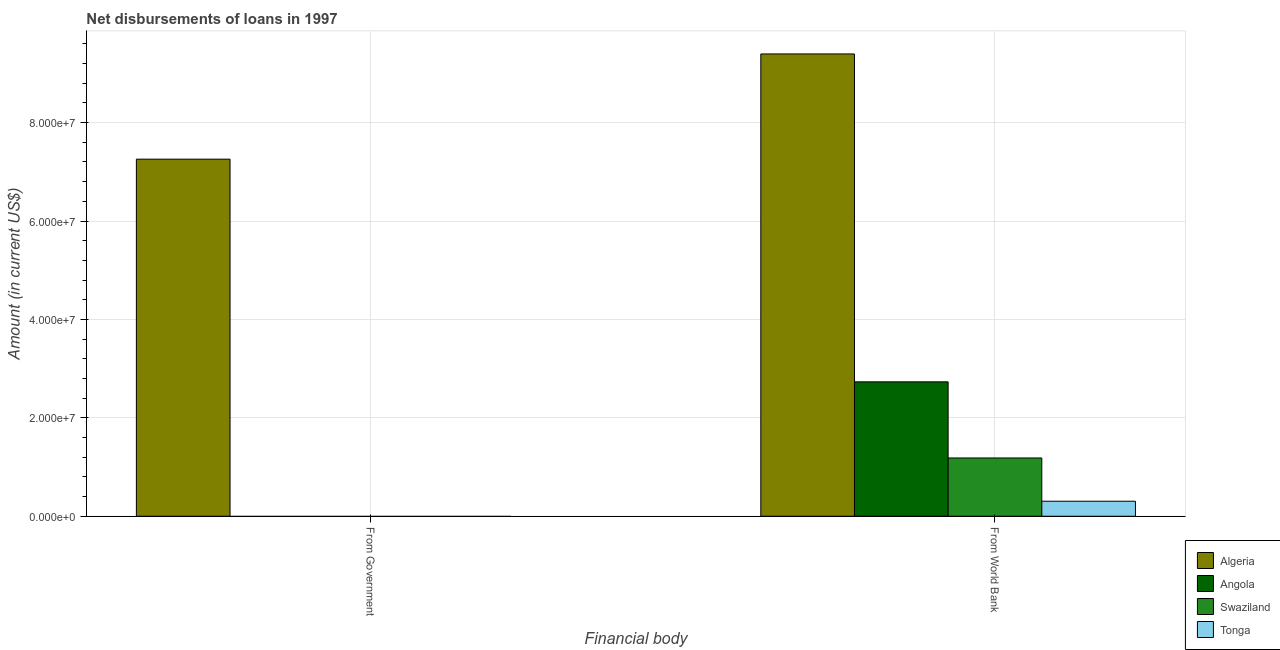How many different coloured bars are there?
Make the answer very short. 4. Are the number of bars per tick equal to the number of legend labels?
Keep it short and to the point. No. Are the number of bars on each tick of the X-axis equal?
Provide a succinct answer. No. How many bars are there on the 1st tick from the left?
Provide a short and direct response. 1. What is the label of the 1st group of bars from the left?
Ensure brevity in your answer.  From Government. Across all countries, what is the maximum net disbursements of loan from world bank?
Provide a short and direct response. 9.40e+07. In which country was the net disbursements of loan from world bank maximum?
Your answer should be very brief. Algeria. What is the total net disbursements of loan from world bank in the graph?
Your answer should be very brief. 1.36e+08. What is the difference between the net disbursements of loan from world bank in Algeria and that in Swaziland?
Your answer should be compact. 8.21e+07. What is the difference between the net disbursements of loan from world bank in Tonga and the net disbursements of loan from government in Swaziland?
Ensure brevity in your answer.  3.05e+06. What is the average net disbursements of loan from world bank per country?
Offer a very short reply. 3.40e+07. What is the difference between the net disbursements of loan from government and net disbursements of loan from world bank in Algeria?
Your answer should be compact. -2.14e+07. In how many countries, is the net disbursements of loan from world bank greater than 84000000 US$?
Your answer should be very brief. 1. What is the ratio of the net disbursements of loan from world bank in Algeria to that in Angola?
Your response must be concise. 3.44. How many countries are there in the graph?
Make the answer very short. 4. What is the difference between two consecutive major ticks on the Y-axis?
Your answer should be compact. 2.00e+07. Are the values on the major ticks of Y-axis written in scientific E-notation?
Provide a short and direct response. Yes. Does the graph contain grids?
Provide a short and direct response. Yes. Where does the legend appear in the graph?
Provide a succinct answer. Bottom right. How many legend labels are there?
Your answer should be compact. 4. How are the legend labels stacked?
Ensure brevity in your answer.  Vertical. What is the title of the graph?
Ensure brevity in your answer.  Net disbursements of loans in 1997. What is the label or title of the X-axis?
Your answer should be compact. Financial body. What is the label or title of the Y-axis?
Offer a terse response. Amount (in current US$). What is the Amount (in current US$) in Algeria in From Government?
Offer a very short reply. 7.26e+07. What is the Amount (in current US$) of Angola in From Government?
Make the answer very short. 0. What is the Amount (in current US$) of Swaziland in From Government?
Provide a short and direct response. 0. What is the Amount (in current US$) in Tonga in From Government?
Make the answer very short. 0. What is the Amount (in current US$) of Algeria in From World Bank?
Your answer should be compact. 9.40e+07. What is the Amount (in current US$) of Angola in From World Bank?
Your answer should be compact. 2.73e+07. What is the Amount (in current US$) in Swaziland in From World Bank?
Your answer should be compact. 1.18e+07. What is the Amount (in current US$) in Tonga in From World Bank?
Provide a short and direct response. 3.05e+06. Across all Financial body, what is the maximum Amount (in current US$) in Algeria?
Provide a short and direct response. 9.40e+07. Across all Financial body, what is the maximum Amount (in current US$) of Angola?
Your answer should be very brief. 2.73e+07. Across all Financial body, what is the maximum Amount (in current US$) of Swaziland?
Offer a terse response. 1.18e+07. Across all Financial body, what is the maximum Amount (in current US$) in Tonga?
Your answer should be compact. 3.05e+06. Across all Financial body, what is the minimum Amount (in current US$) in Algeria?
Offer a terse response. 7.26e+07. Across all Financial body, what is the minimum Amount (in current US$) of Angola?
Give a very brief answer. 0. Across all Financial body, what is the minimum Amount (in current US$) in Tonga?
Offer a very short reply. 0. What is the total Amount (in current US$) of Algeria in the graph?
Your response must be concise. 1.67e+08. What is the total Amount (in current US$) of Angola in the graph?
Provide a short and direct response. 2.73e+07. What is the total Amount (in current US$) of Swaziland in the graph?
Keep it short and to the point. 1.18e+07. What is the total Amount (in current US$) in Tonga in the graph?
Provide a succinct answer. 3.05e+06. What is the difference between the Amount (in current US$) in Algeria in From Government and that in From World Bank?
Give a very brief answer. -2.14e+07. What is the difference between the Amount (in current US$) in Algeria in From Government and the Amount (in current US$) in Angola in From World Bank?
Provide a short and direct response. 4.53e+07. What is the difference between the Amount (in current US$) of Algeria in From Government and the Amount (in current US$) of Swaziland in From World Bank?
Provide a short and direct response. 6.07e+07. What is the difference between the Amount (in current US$) in Algeria in From Government and the Amount (in current US$) in Tonga in From World Bank?
Keep it short and to the point. 6.95e+07. What is the average Amount (in current US$) in Algeria per Financial body?
Give a very brief answer. 8.33e+07. What is the average Amount (in current US$) of Angola per Financial body?
Offer a very short reply. 1.37e+07. What is the average Amount (in current US$) in Swaziland per Financial body?
Ensure brevity in your answer.  5.92e+06. What is the average Amount (in current US$) in Tonga per Financial body?
Your answer should be compact. 1.53e+06. What is the difference between the Amount (in current US$) of Algeria and Amount (in current US$) of Angola in From World Bank?
Provide a succinct answer. 6.66e+07. What is the difference between the Amount (in current US$) of Algeria and Amount (in current US$) of Swaziland in From World Bank?
Keep it short and to the point. 8.21e+07. What is the difference between the Amount (in current US$) of Algeria and Amount (in current US$) of Tonga in From World Bank?
Your response must be concise. 9.09e+07. What is the difference between the Amount (in current US$) in Angola and Amount (in current US$) in Swaziland in From World Bank?
Ensure brevity in your answer.  1.55e+07. What is the difference between the Amount (in current US$) in Angola and Amount (in current US$) in Tonga in From World Bank?
Your answer should be compact. 2.43e+07. What is the difference between the Amount (in current US$) in Swaziland and Amount (in current US$) in Tonga in From World Bank?
Keep it short and to the point. 8.79e+06. What is the ratio of the Amount (in current US$) of Algeria in From Government to that in From World Bank?
Ensure brevity in your answer.  0.77. What is the difference between the highest and the second highest Amount (in current US$) of Algeria?
Your response must be concise. 2.14e+07. What is the difference between the highest and the lowest Amount (in current US$) in Algeria?
Ensure brevity in your answer.  2.14e+07. What is the difference between the highest and the lowest Amount (in current US$) of Angola?
Provide a short and direct response. 2.73e+07. What is the difference between the highest and the lowest Amount (in current US$) in Swaziland?
Your answer should be compact. 1.18e+07. What is the difference between the highest and the lowest Amount (in current US$) in Tonga?
Your response must be concise. 3.05e+06. 